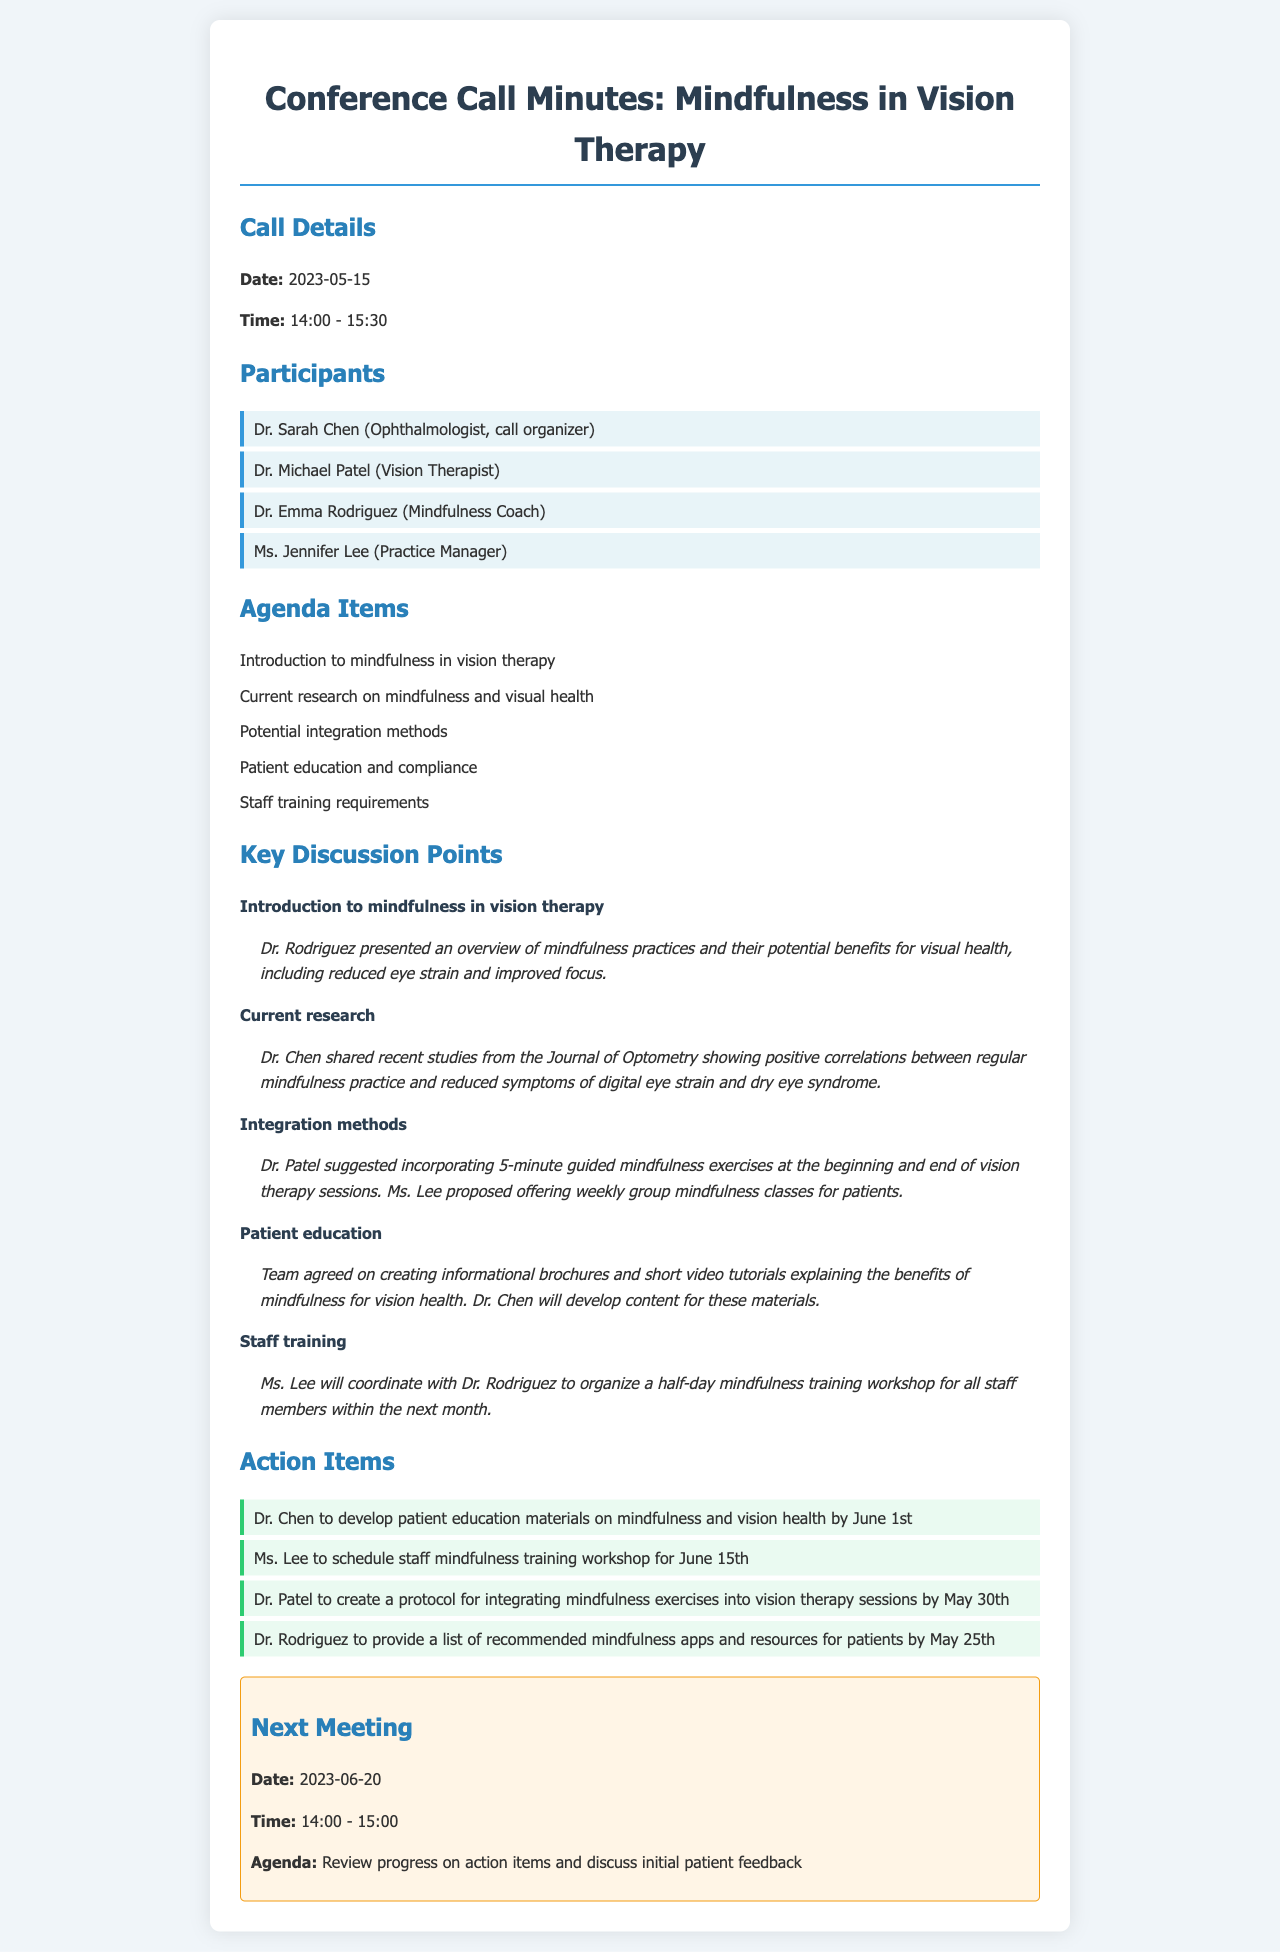What is the date of the conference call? The date of the conference call is mentioned in the Call Details section of the document.
Answer: 2023-05-15 Who organized the call? The organizer of the call is identified in the Participants section.
Answer: Dr. Sarah Chen What is one potential method for integration of mindfulness into vision therapy? A specific method is noted in the Key Discussion Points regarding mindfulness exercises proposed by Dr. Patel.
Answer: 5-minute guided mindfulness exercises What will Dr. Chen develop? Dr. Chen's task is listed in the Action Items section of the document.
Answer: Patient education materials When is the next scheduled meeting? The next meeting is documented in the Next Meeting section with details provided.
Answer: 2023-06-20 What did Dr. Rodriguez present? Dr. Rodriguez's presentation topic is discussed in the Key Discussion Points section.
Answer: Overview of mindfulness practices What is the purpose of the upcoming staff training workshop? The purpose relates to the discussion of staff training requirements highlighted in the document.
Answer: Mindfulness training How long is the duration of the conference call? The total duration is specified in the Call Details section.
Answer: 1 hour 30 minutes Which participant is a Mindfulness Coach? The Participants list clearly identifies the role of each participant.
Answer: Dr. Emma Rodriguez 